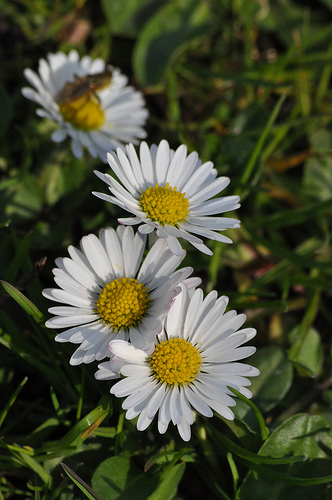<image>
Is there a flower behind the leaf? No. The flower is not behind the leaf. From this viewpoint, the flower appears to be positioned elsewhere in the scene. 